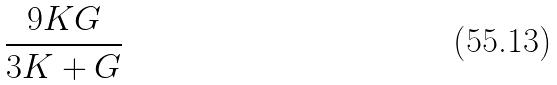Convert formula to latex. <formula><loc_0><loc_0><loc_500><loc_500>\frac { 9 K G } { 3 K + G }</formula> 